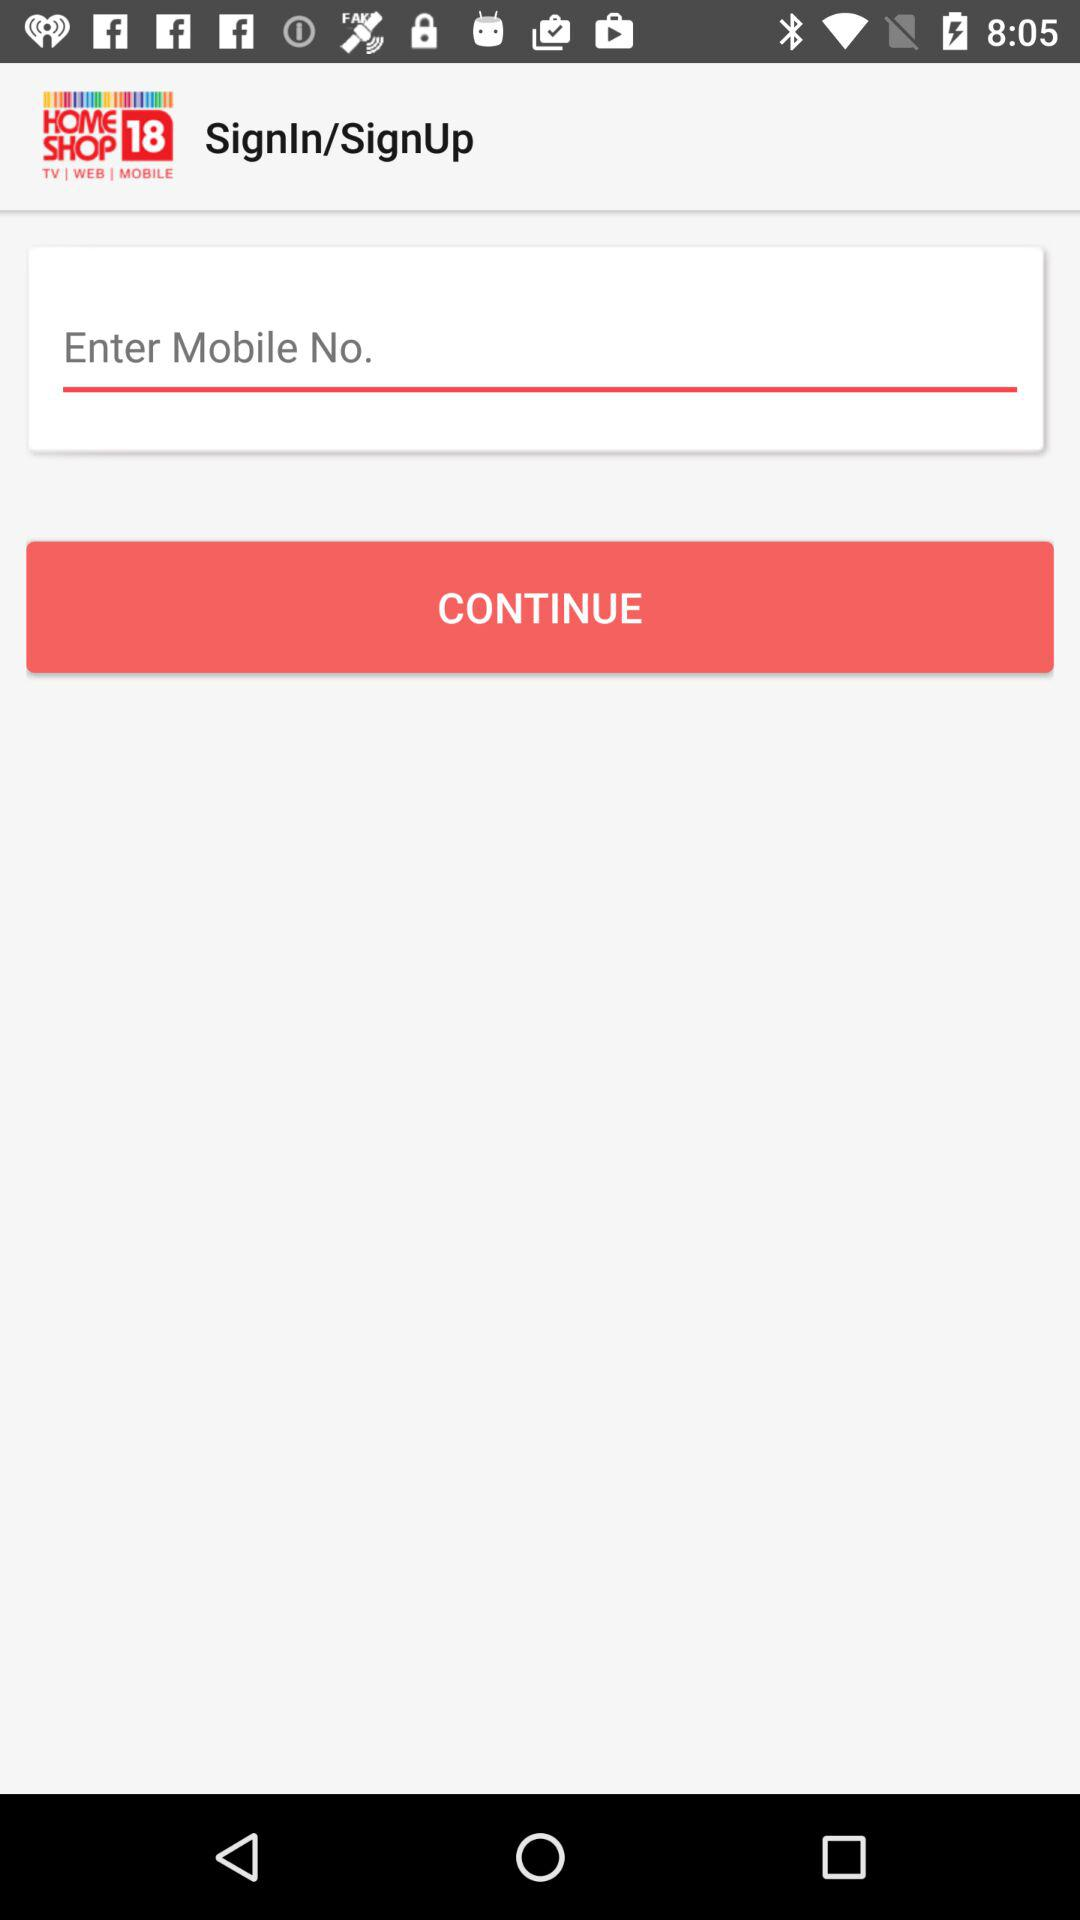Who referred the user?
When the provided information is insufficient, respond with <no answer>. <no answer> 